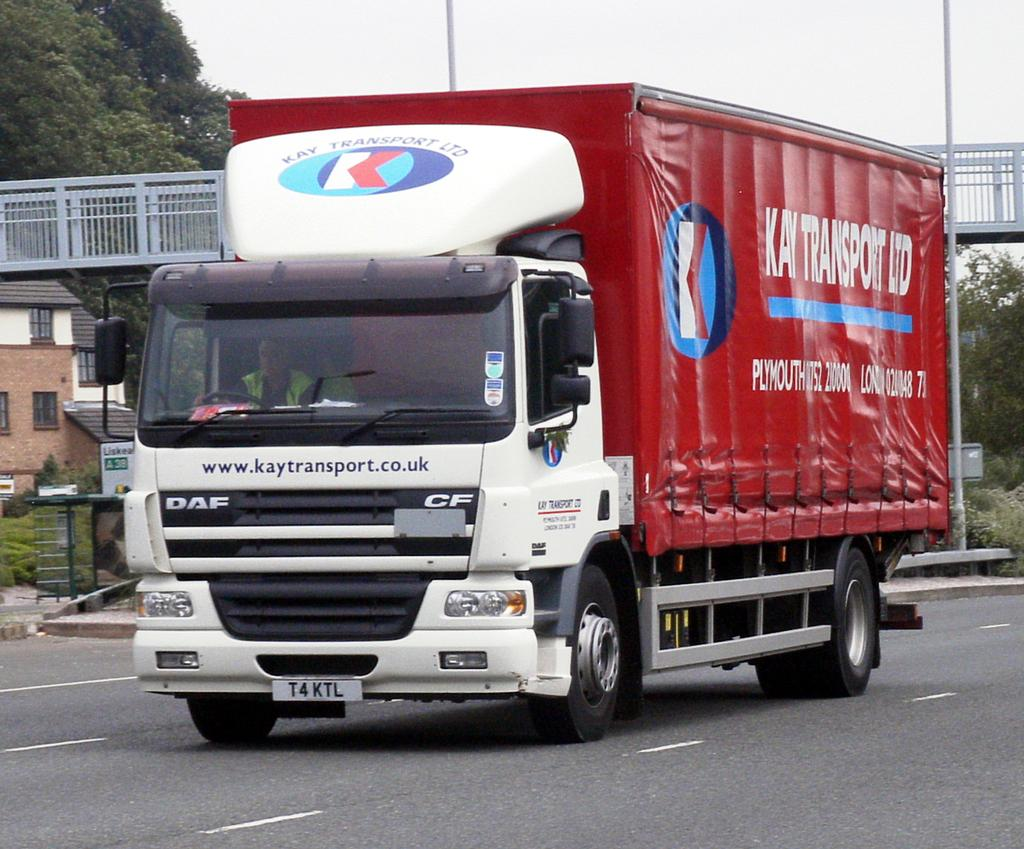What is the person in the image doing? The person is in a vehicle in the image. Where is the vehicle located? The vehicle is on the road. What can be seen in the background of the image? A bridge, plants, poles, and a building are visible in the background of the image. What type of knee injury can be seen in the image? There is no knee injury present in the image; it features a person in a vehicle on the road. What amusement park can be seen in the background of the image? There is no amusement park visible in the image; it features a bridge, plants, poles, and a building in the background. 